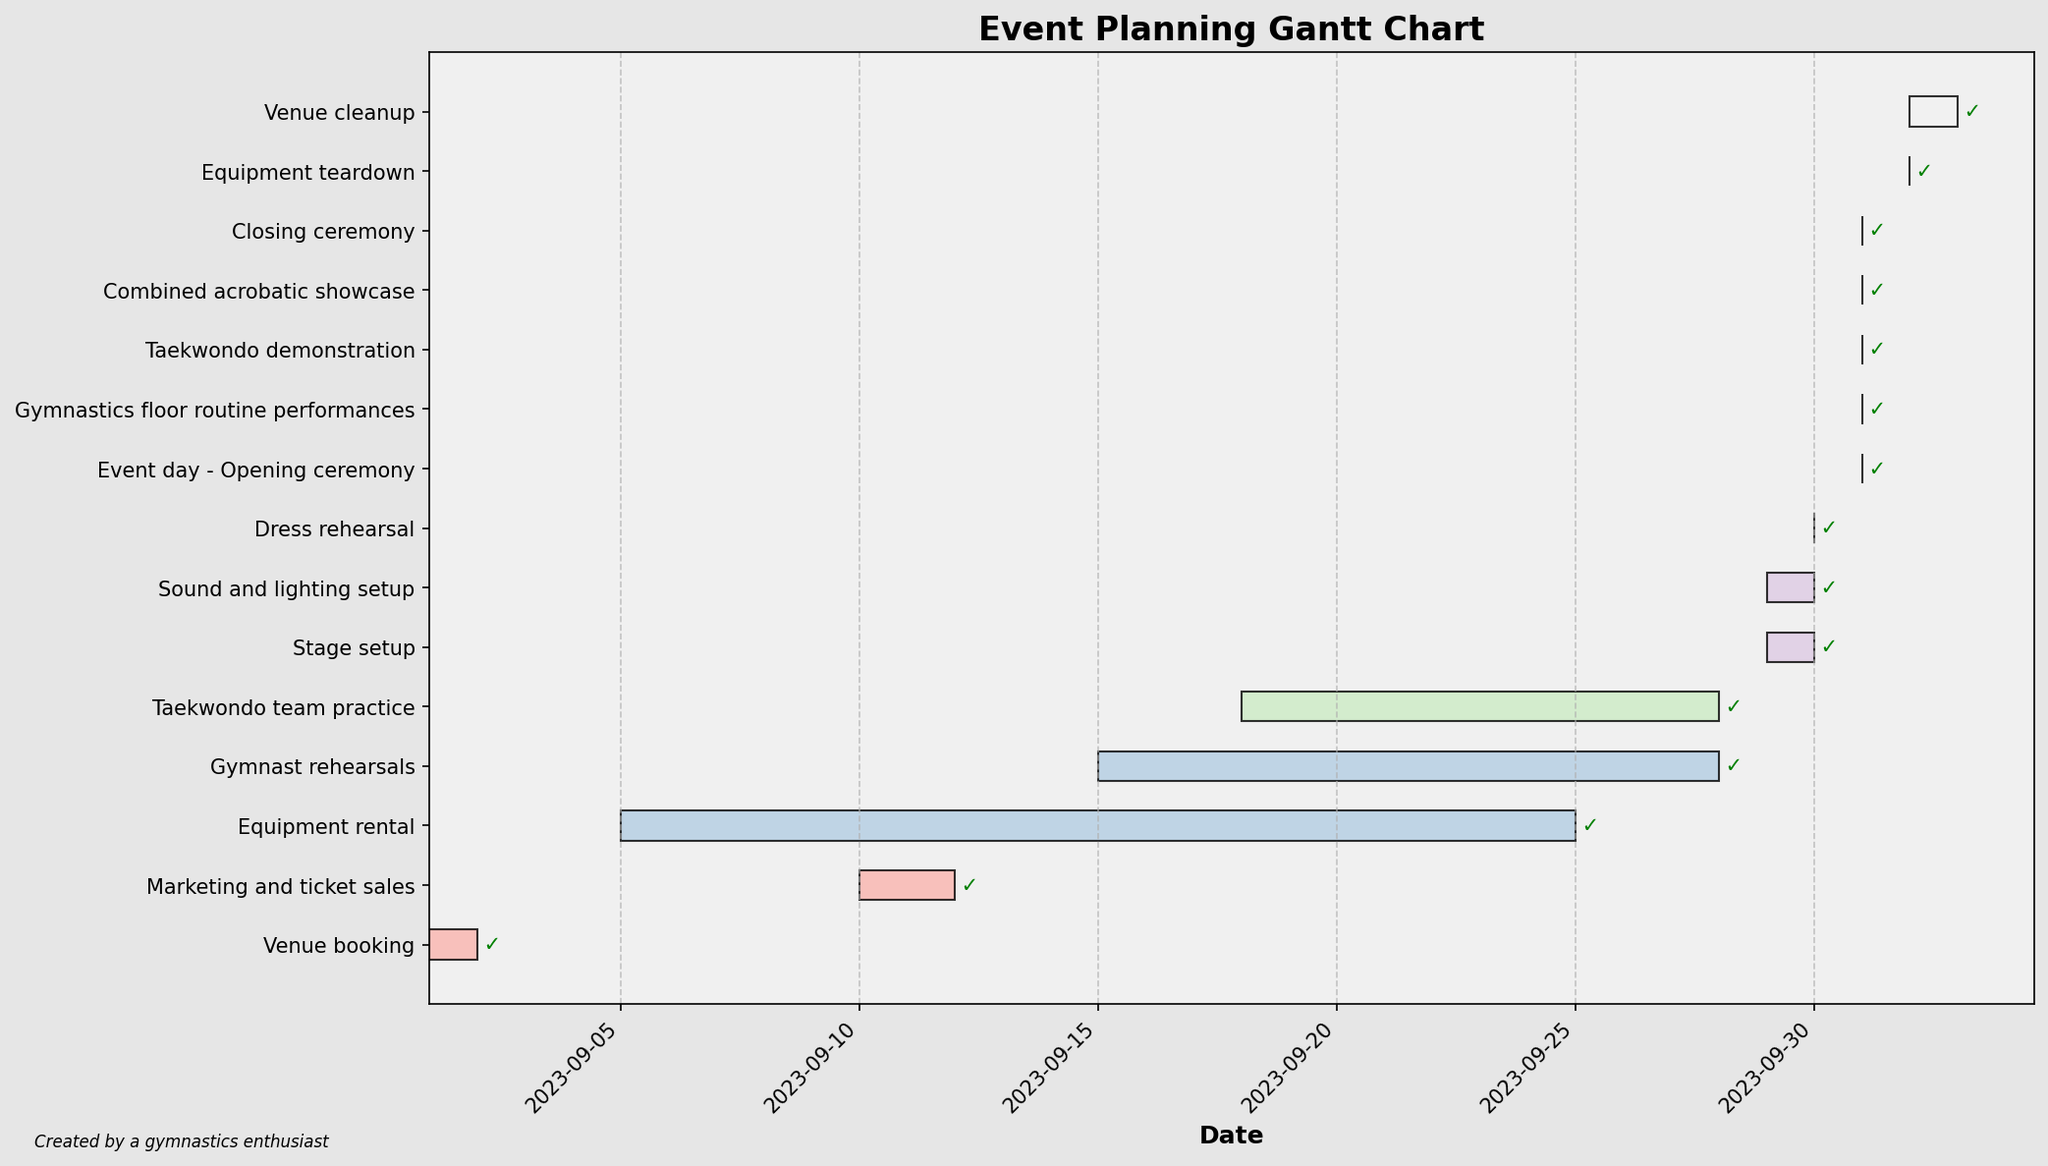What is the title of the chart? The title of the chart is located at the top center. It usually provides a summary of what the chart is about.
Answer: Event Planning Gantt Chart On what date does the 'Gymnast rehearsals' task start and end? To find the start and end dates for a specific task, look at the corresponding bar's beginning and end along the x-axis. For 'Gymnast rehearsals,' the bar starts at September 15, 2023, and ends at September 28, 2023.
Answer: September 15, 2023 to September 28, 2023 How many tasks are listed in the Gantt chart? Count the number of horizontal bars, each representing a task, depicted on the y-axis of the chart. There are 15 tasks listed.
Answer: 15 Which task takes the longest time to complete? Compare the lengths of all the horizontal bars representing tasks. The longest bar corresponds to the task 'Marketing and ticket sales.'
Answer: Marketing and ticket sales What is the overlap period between 'Gymnast rehearsals' and 'Taekwondo team practice'? Identify the start and end dates of both tasks. 'Gymnast rehearsals' runs from September 15 to September 28, and 'Taekwondo team practice' runs from September 18 to September 28. The overlap period is from September 18 to September 28.
Answer: 11 days Which tasks are scheduled on the same day as the 'Event day - Opening ceremony'? Locate the 'Event day - Opening ceremony' and examine other tasks that have the same date. The tasks are 'Opening ceremony,' 'Gymnastics floor routine performances,' 'Taekwondo demonstration,' 'Combined acrobatic showcase,' and 'Closing ceremony.'
Answer: Opening ceremony, Gymnastics floor routine performances, Taekwondo demonstration, Combined acrobatic showcase, Closing ceremony How many tasks are scheduled to be completed in September 2023? Count the bars that have their end dates in September 2023. They are 'Venue booking,' 'Equipment rental,' 'Marketing and ticket sales,' 'Gymnast rehearsals,' 'Taekwondo team practice,' 'Stage setup,' 'Sound and lighting setup,' and 'Dress rehearsal.'
Answer: 8 What tasks take place right after the 'Stage setup'? Find the end date of the 'Stage setup' and identify the tasks that start immediately after. 'Stage setup' ends on September 30. The task that takes place next is 'Dress rehearsal.'
Answer: Dress rehearsal Which tasks are scheduled for the shortest duration? Look for the bars that have the shortest length along the x-axis. The tasks 'Venue booking,' 'Stage setup,' 'Sound and lighting setup,' 'Dress rehearsal,' 'Event day - Opening ceremony,' 'Gymnastics floor routine performances,' 'Taekwondo demonstration,' 'Combined acrobatic showcase,' 'Closing ceremony,' 'Equipment teardown,' and 'Venue cleanup' all have a duration of 1 day.
Answer: Venue booking, Stage setup, Sound and lighting setup, Dress rehearsal, Event day - Opening ceremony, Gymnastics floor routine performances, Taekwondo demonstration, Combined acrobatic showcase, Closing ceremony, Equipment teardown, Venue cleanup 